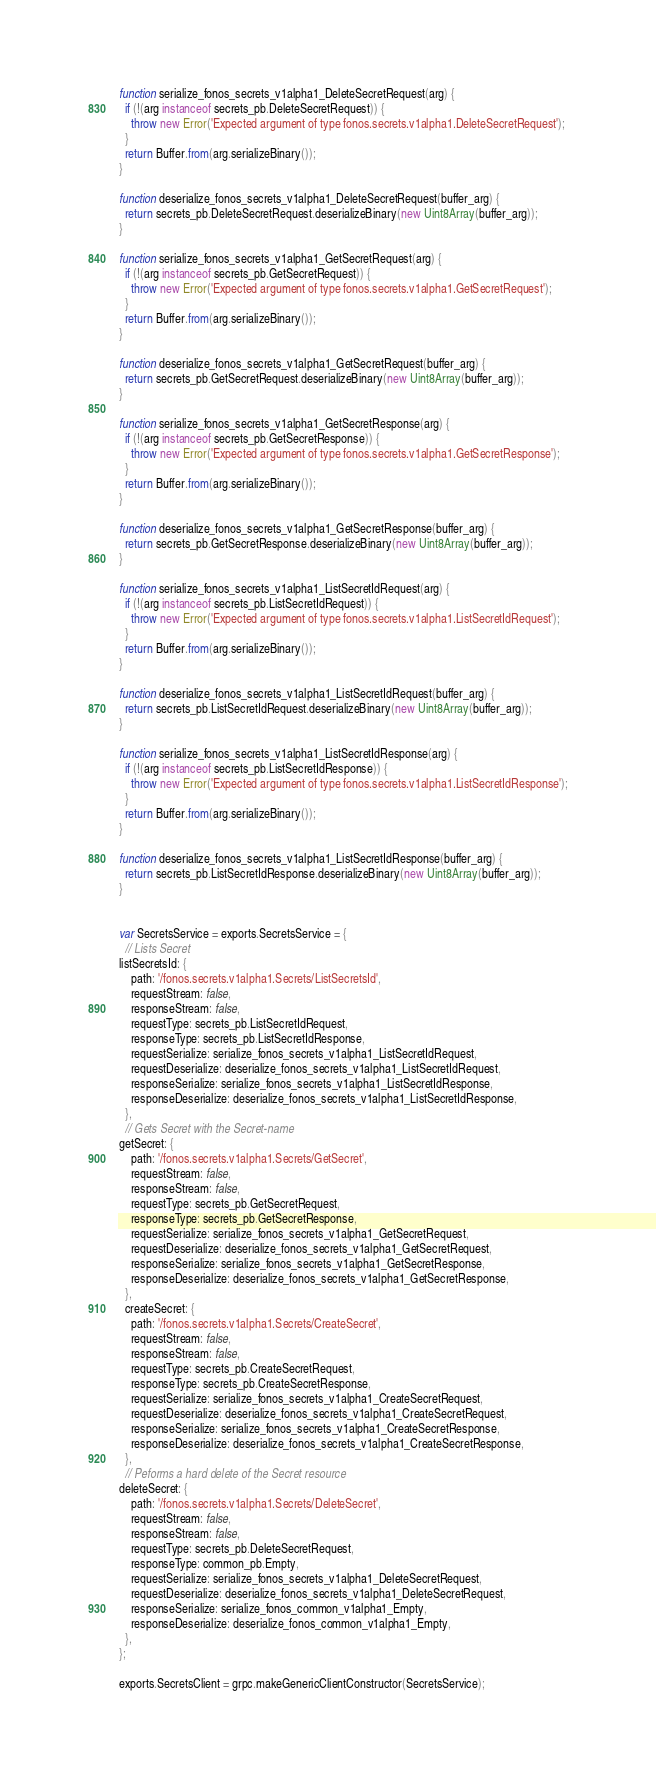Convert code to text. <code><loc_0><loc_0><loc_500><loc_500><_JavaScript_>
function serialize_fonos_secrets_v1alpha1_DeleteSecretRequest(arg) {
  if (!(arg instanceof secrets_pb.DeleteSecretRequest)) {
    throw new Error('Expected argument of type fonos.secrets.v1alpha1.DeleteSecretRequest');
  }
  return Buffer.from(arg.serializeBinary());
}

function deserialize_fonos_secrets_v1alpha1_DeleteSecretRequest(buffer_arg) {
  return secrets_pb.DeleteSecretRequest.deserializeBinary(new Uint8Array(buffer_arg));
}

function serialize_fonos_secrets_v1alpha1_GetSecretRequest(arg) {
  if (!(arg instanceof secrets_pb.GetSecretRequest)) {
    throw new Error('Expected argument of type fonos.secrets.v1alpha1.GetSecretRequest');
  }
  return Buffer.from(arg.serializeBinary());
}

function deserialize_fonos_secrets_v1alpha1_GetSecretRequest(buffer_arg) {
  return secrets_pb.GetSecretRequest.deserializeBinary(new Uint8Array(buffer_arg));
}

function serialize_fonos_secrets_v1alpha1_GetSecretResponse(arg) {
  if (!(arg instanceof secrets_pb.GetSecretResponse)) {
    throw new Error('Expected argument of type fonos.secrets.v1alpha1.GetSecretResponse');
  }
  return Buffer.from(arg.serializeBinary());
}

function deserialize_fonos_secrets_v1alpha1_GetSecretResponse(buffer_arg) {
  return secrets_pb.GetSecretResponse.deserializeBinary(new Uint8Array(buffer_arg));
}

function serialize_fonos_secrets_v1alpha1_ListSecretIdRequest(arg) {
  if (!(arg instanceof secrets_pb.ListSecretIdRequest)) {
    throw new Error('Expected argument of type fonos.secrets.v1alpha1.ListSecretIdRequest');
  }
  return Buffer.from(arg.serializeBinary());
}

function deserialize_fonos_secrets_v1alpha1_ListSecretIdRequest(buffer_arg) {
  return secrets_pb.ListSecretIdRequest.deserializeBinary(new Uint8Array(buffer_arg));
}

function serialize_fonos_secrets_v1alpha1_ListSecretIdResponse(arg) {
  if (!(arg instanceof secrets_pb.ListSecretIdResponse)) {
    throw new Error('Expected argument of type fonos.secrets.v1alpha1.ListSecretIdResponse');
  }
  return Buffer.from(arg.serializeBinary());
}

function deserialize_fonos_secrets_v1alpha1_ListSecretIdResponse(buffer_arg) {
  return secrets_pb.ListSecretIdResponse.deserializeBinary(new Uint8Array(buffer_arg));
}


var SecretsService = exports.SecretsService = {
  // Lists Secret 
listSecretsId: {
    path: '/fonos.secrets.v1alpha1.Secrets/ListSecretsId',
    requestStream: false,
    responseStream: false,
    requestType: secrets_pb.ListSecretIdRequest,
    responseType: secrets_pb.ListSecretIdResponse,
    requestSerialize: serialize_fonos_secrets_v1alpha1_ListSecretIdRequest,
    requestDeserialize: deserialize_fonos_secrets_v1alpha1_ListSecretIdRequest,
    responseSerialize: serialize_fonos_secrets_v1alpha1_ListSecretIdResponse,
    responseDeserialize: deserialize_fonos_secrets_v1alpha1_ListSecretIdResponse,
  },
  // Gets Secret with the Secret-name
getSecret: {
    path: '/fonos.secrets.v1alpha1.Secrets/GetSecret',
    requestStream: false,
    responseStream: false,
    requestType: secrets_pb.GetSecretRequest,
    responseType: secrets_pb.GetSecretResponse,
    requestSerialize: serialize_fonos_secrets_v1alpha1_GetSecretRequest,
    requestDeserialize: deserialize_fonos_secrets_v1alpha1_GetSecretRequest,
    responseSerialize: serialize_fonos_secrets_v1alpha1_GetSecretResponse,
    responseDeserialize: deserialize_fonos_secrets_v1alpha1_GetSecretResponse,
  },
  createSecret: {
    path: '/fonos.secrets.v1alpha1.Secrets/CreateSecret',
    requestStream: false,
    responseStream: false,
    requestType: secrets_pb.CreateSecretRequest,
    responseType: secrets_pb.CreateSecretResponse,
    requestSerialize: serialize_fonos_secrets_v1alpha1_CreateSecretRequest,
    requestDeserialize: deserialize_fonos_secrets_v1alpha1_CreateSecretRequest,
    responseSerialize: serialize_fonos_secrets_v1alpha1_CreateSecretResponse,
    responseDeserialize: deserialize_fonos_secrets_v1alpha1_CreateSecretResponse,
  },
  // Peforms a hard delete of the Secret resource
deleteSecret: {
    path: '/fonos.secrets.v1alpha1.Secrets/DeleteSecret',
    requestStream: false,
    responseStream: false,
    requestType: secrets_pb.DeleteSecretRequest,
    responseType: common_pb.Empty,
    requestSerialize: serialize_fonos_secrets_v1alpha1_DeleteSecretRequest,
    requestDeserialize: deserialize_fonos_secrets_v1alpha1_DeleteSecretRequest,
    responseSerialize: serialize_fonos_common_v1alpha1_Empty,
    responseDeserialize: deserialize_fonos_common_v1alpha1_Empty,
  },
};

exports.SecretsClient = grpc.makeGenericClientConstructor(SecretsService);
</code> 